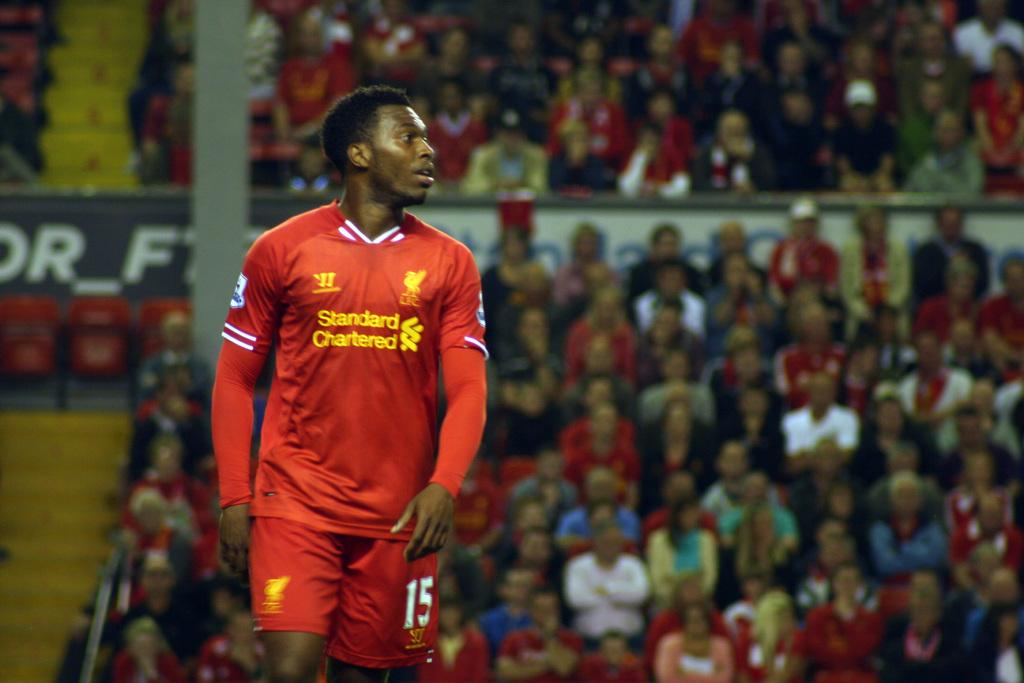Provide a one-sentence caption for the provided image. Man wearing a red jersey with yellow letters that say Standard Chartered. 